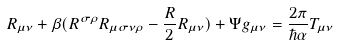Convert formula to latex. <formula><loc_0><loc_0><loc_500><loc_500>R _ { \mu \nu } + \beta ( R ^ { \sigma \rho } R _ { \mu \sigma \nu \rho } - \frac { R } { 2 } R _ { \mu \nu } ) + \Psi g _ { \mu \nu } = \frac { 2 \pi } { \hbar { \alpha } } T _ { \mu \nu }</formula> 